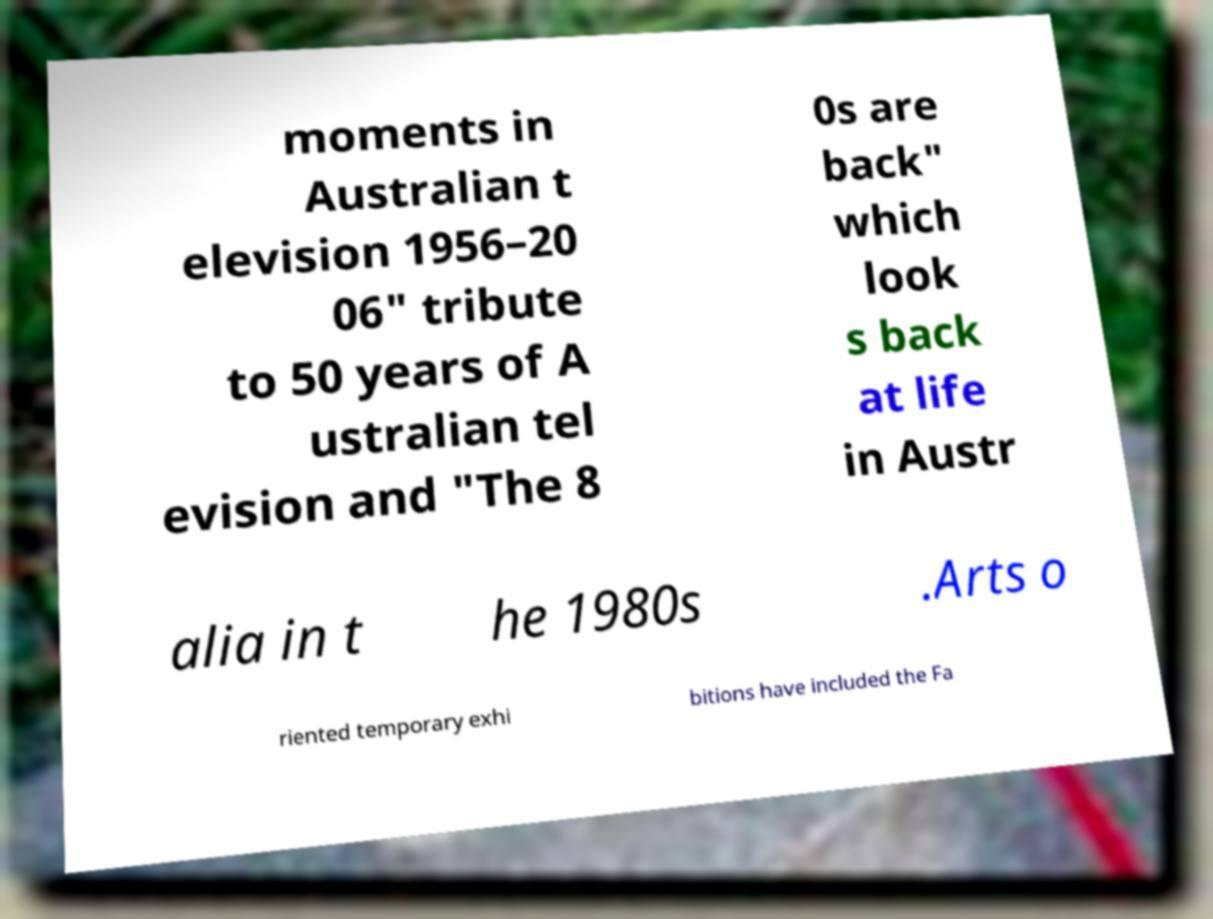For documentation purposes, I need the text within this image transcribed. Could you provide that? moments in Australian t elevision 1956–20 06" tribute to 50 years of A ustralian tel evision and "The 8 0s are back" which look s back at life in Austr alia in t he 1980s .Arts o riented temporary exhi bitions have included the Fa 